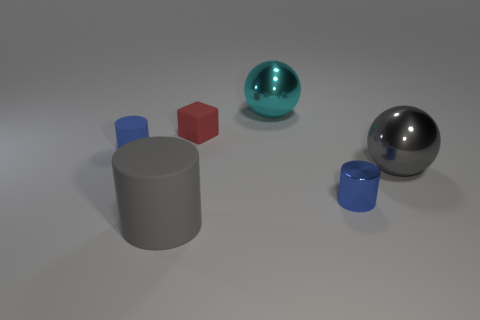How would the shadow of the red cube compare to that of the blue cylinder if a light source were positioned above them? The shadow of the red cube would have a sharp, square shape, while the shadow of the blue cylinder would appear as an elongated oval or rectangle, depending on the angle of the light source. 